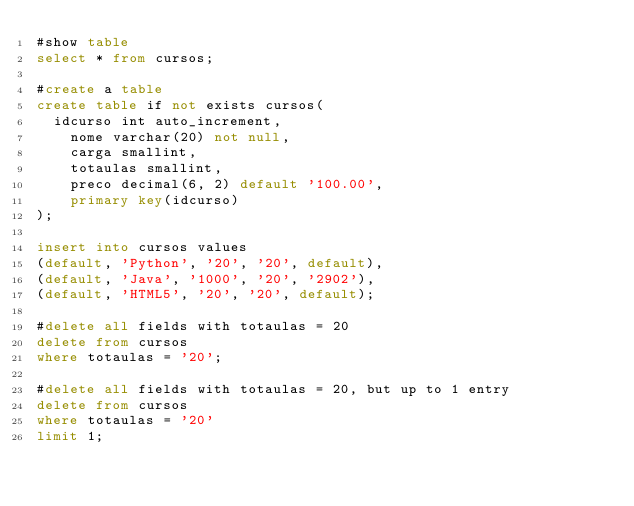Convert code to text. <code><loc_0><loc_0><loc_500><loc_500><_SQL_>#show table
select * from cursos;

#create a table
create table if not exists cursos(
	idcurso int auto_increment,
    nome varchar(20) not null,
    carga smallint,
    totaulas smallint,
    preco decimal(6, 2) default '100.00',
    primary key(idcurso)
);

insert into cursos values
(default, 'Python', '20', '20', default),
(default, 'Java', '1000', '20', '2902'),
(default, 'HTML5', '20', '20', default);

#delete all fields with totaulas = 20
delete from cursos
where totaulas = '20';

#delete all fields with totaulas = 20, but up to 1 entry
delete from cursos
where totaulas = '20'
limit 1;</code> 